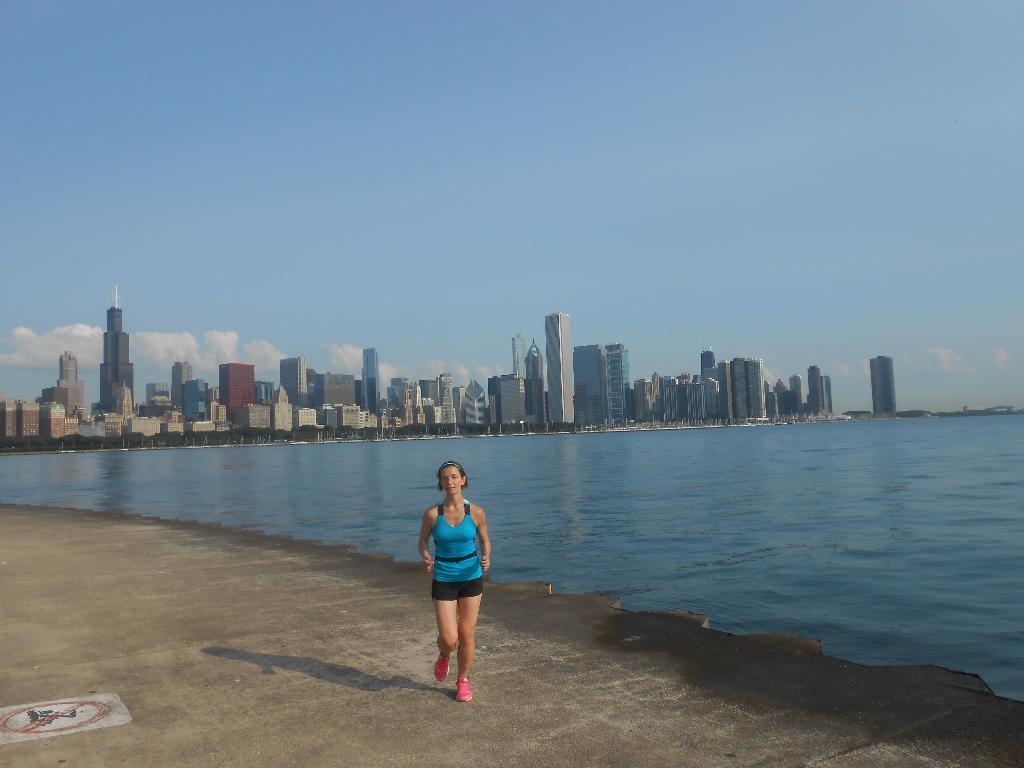Can you describe this image briefly? In the image in the center, we can see one woman running. In the background, we can see the sky, clouds, buildings, towers, trees and water. 